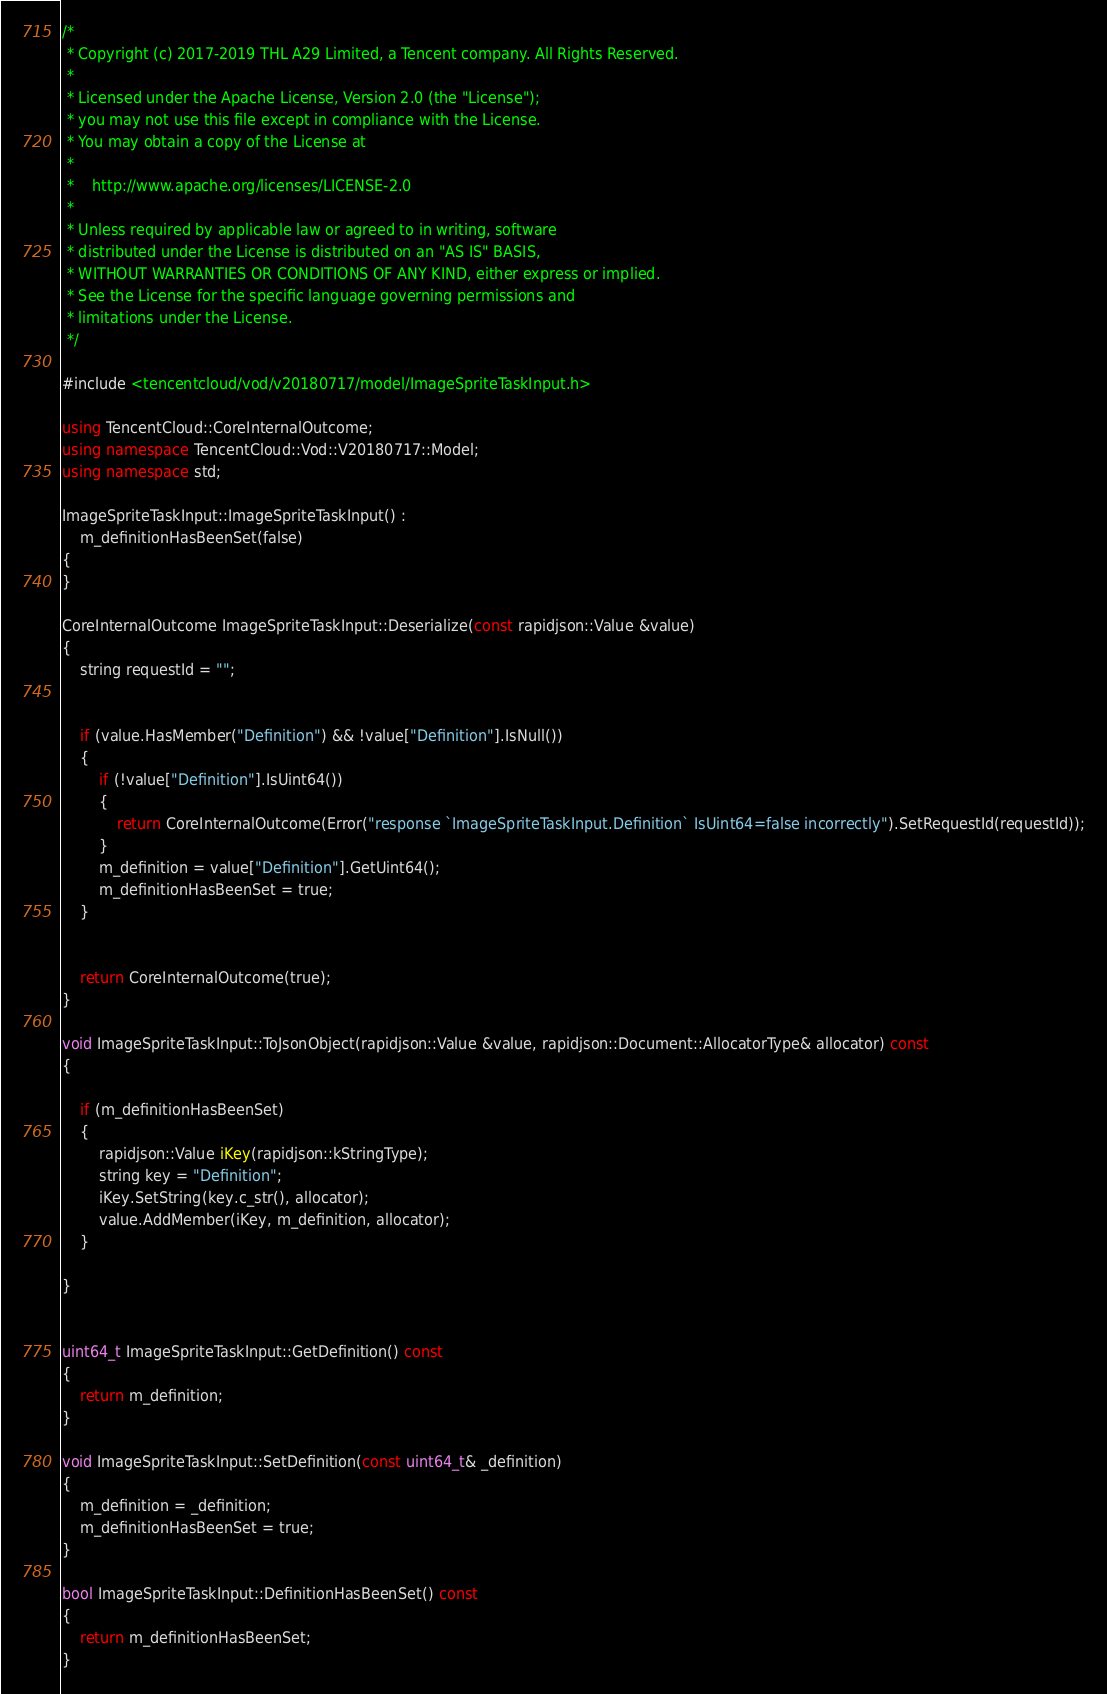Convert code to text. <code><loc_0><loc_0><loc_500><loc_500><_C++_>/*
 * Copyright (c) 2017-2019 THL A29 Limited, a Tencent company. All Rights Reserved.
 *
 * Licensed under the Apache License, Version 2.0 (the "License");
 * you may not use this file except in compliance with the License.
 * You may obtain a copy of the License at
 *
 *    http://www.apache.org/licenses/LICENSE-2.0
 *
 * Unless required by applicable law or agreed to in writing, software
 * distributed under the License is distributed on an "AS IS" BASIS,
 * WITHOUT WARRANTIES OR CONDITIONS OF ANY KIND, either express or implied.
 * See the License for the specific language governing permissions and
 * limitations under the License.
 */

#include <tencentcloud/vod/v20180717/model/ImageSpriteTaskInput.h>

using TencentCloud::CoreInternalOutcome;
using namespace TencentCloud::Vod::V20180717::Model;
using namespace std;

ImageSpriteTaskInput::ImageSpriteTaskInput() :
    m_definitionHasBeenSet(false)
{
}

CoreInternalOutcome ImageSpriteTaskInput::Deserialize(const rapidjson::Value &value)
{
    string requestId = "";


    if (value.HasMember("Definition") && !value["Definition"].IsNull())
    {
        if (!value["Definition"].IsUint64())
        {
            return CoreInternalOutcome(Error("response `ImageSpriteTaskInput.Definition` IsUint64=false incorrectly").SetRequestId(requestId));
        }
        m_definition = value["Definition"].GetUint64();
        m_definitionHasBeenSet = true;
    }


    return CoreInternalOutcome(true);
}

void ImageSpriteTaskInput::ToJsonObject(rapidjson::Value &value, rapidjson::Document::AllocatorType& allocator) const
{

    if (m_definitionHasBeenSet)
    {
        rapidjson::Value iKey(rapidjson::kStringType);
        string key = "Definition";
        iKey.SetString(key.c_str(), allocator);
        value.AddMember(iKey, m_definition, allocator);
    }

}


uint64_t ImageSpriteTaskInput::GetDefinition() const
{
    return m_definition;
}

void ImageSpriteTaskInput::SetDefinition(const uint64_t& _definition)
{
    m_definition = _definition;
    m_definitionHasBeenSet = true;
}

bool ImageSpriteTaskInput::DefinitionHasBeenSet() const
{
    return m_definitionHasBeenSet;
}

</code> 